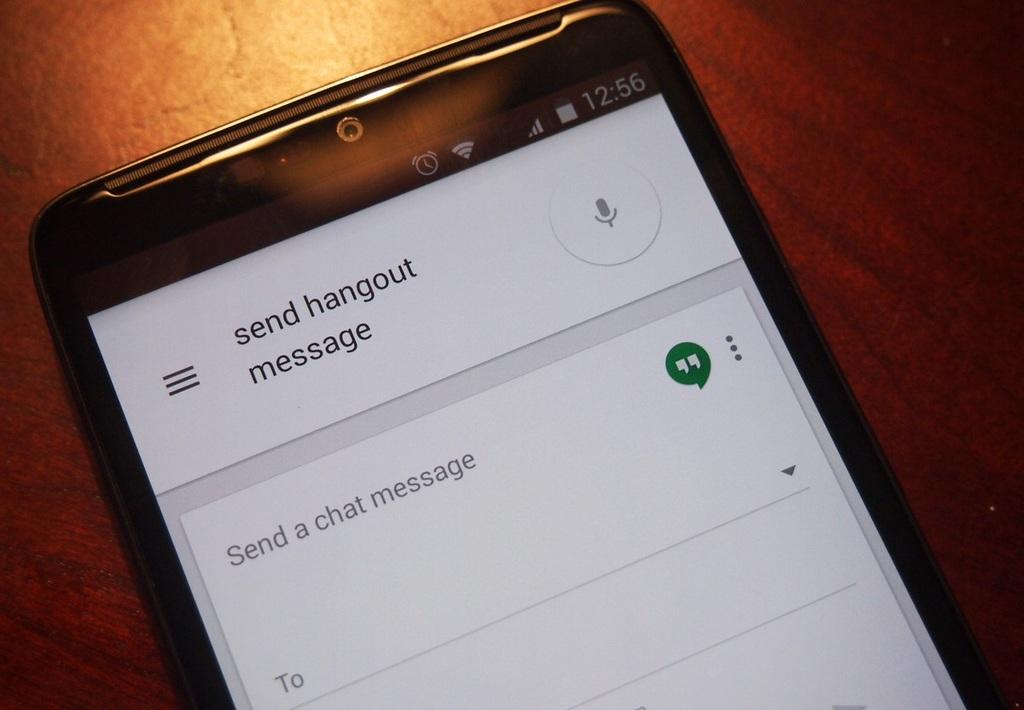Provide a one-sentence caption for the provided image. a phone settings page where send hangout is at the top. 